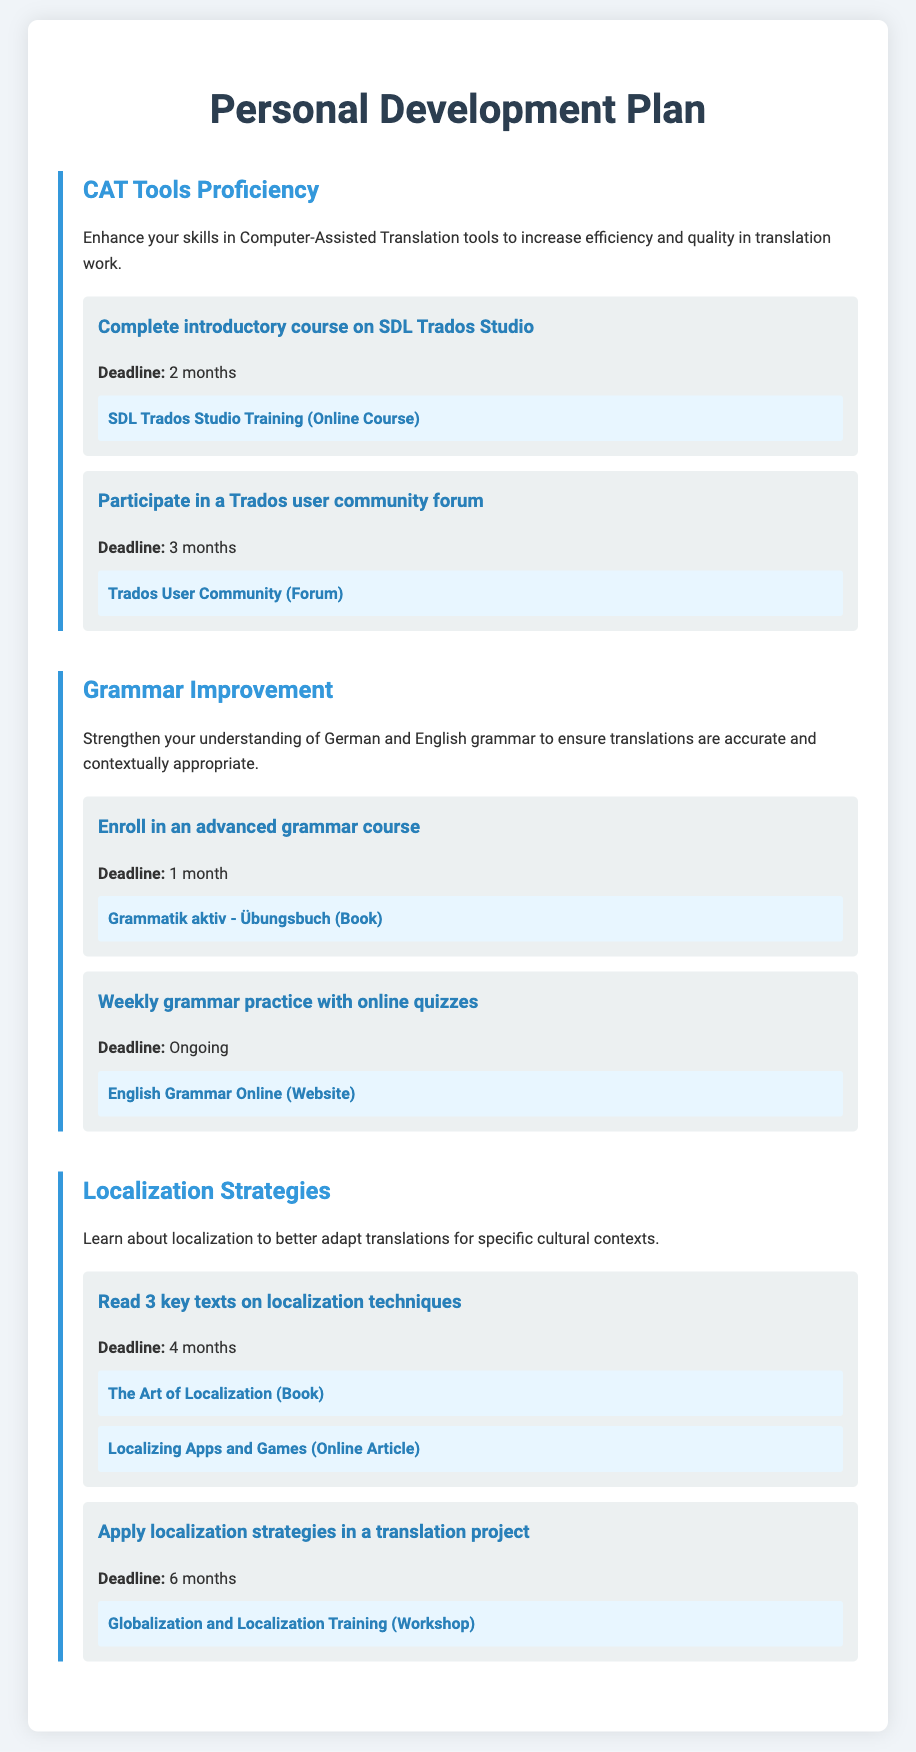What is the first skill listed in the plan? The first skill listed in the document is CAT Tools Proficiency.
Answer: CAT Tools Proficiency What is the deadline for completing the introductory course on SDL Trados Studio? The deadline for completing the introductory course is 2 months.
Answer: 2 months How many key texts on localization techniques should be read? The document specifies reading 3 key texts on localization techniques.
Answer: 3 What online resource is recommended for weekly grammar practice? The recommended online resource for weekly grammar practice is the English Grammar Online website.
Answer: English Grammar Online What is the main goal of improving localization strategies? The main goal is to better adapt translations for specific cultural contexts.
Answer: adapt translations Which book is suggested for grammar improvement? The suggested book for grammar improvement is "Grammatik aktiv - Übungsbuch."
Answer: Grammatik aktiv - Übungsbuch What is the resource type for the "Trados User Community"? The resource type for the "Trados User Community" is a forum.
Answer: forum What is the deadline for applying localization strategies in a project? The deadline for applying localization strategies is 6 months.
Answer: 6 months 